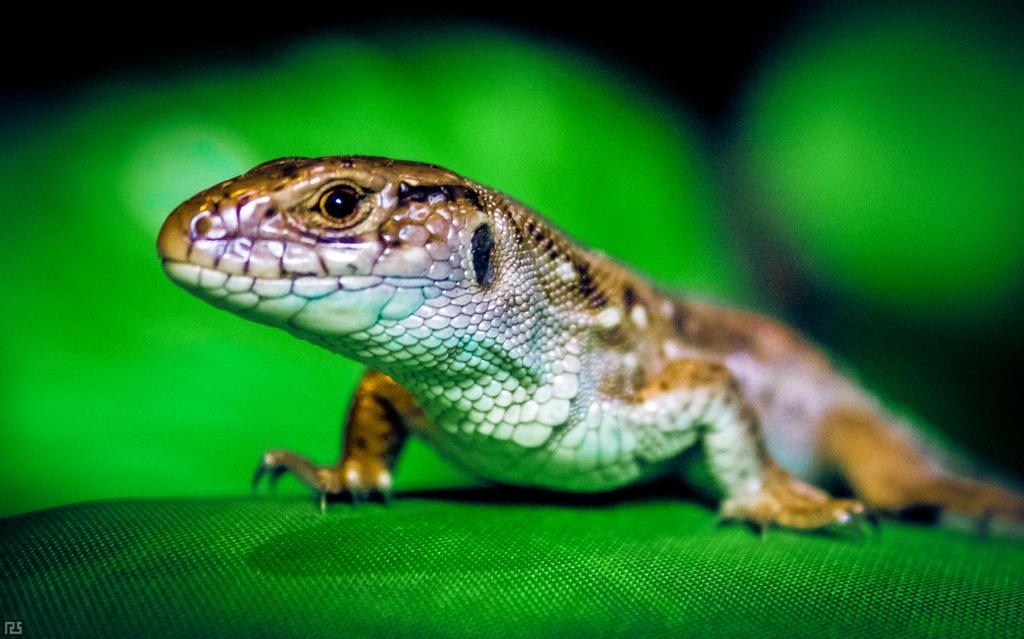In one or two sentences, can you explain what this image depicts? In this image there is a lizard on the green surface, the background of the image is green in color. 